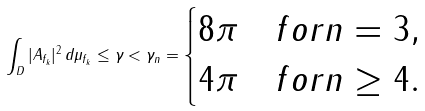Convert formula to latex. <formula><loc_0><loc_0><loc_500><loc_500>\int _ { D } | A _ { f _ { k } } | ^ { 2 } \, d \mu _ { f _ { k } } \leq \gamma < \gamma _ { n } = \begin{cases} 8 \pi & f o r n = 3 , \\ 4 \pi & f o r n \geq 4 . \end{cases}</formula> 